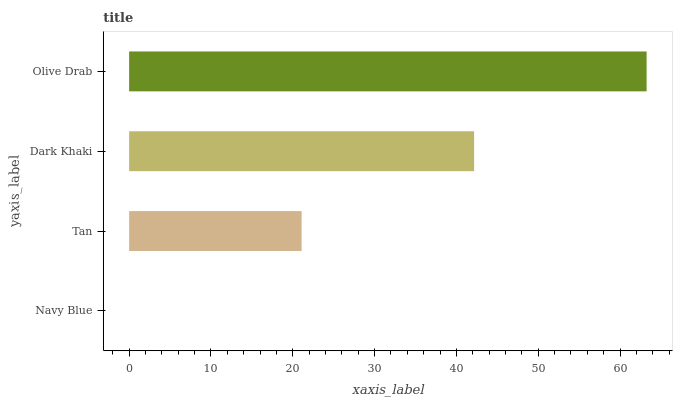Is Navy Blue the minimum?
Answer yes or no. Yes. Is Olive Drab the maximum?
Answer yes or no. Yes. Is Tan the minimum?
Answer yes or no. No. Is Tan the maximum?
Answer yes or no. No. Is Tan greater than Navy Blue?
Answer yes or no. Yes. Is Navy Blue less than Tan?
Answer yes or no. Yes. Is Navy Blue greater than Tan?
Answer yes or no. No. Is Tan less than Navy Blue?
Answer yes or no. No. Is Dark Khaki the high median?
Answer yes or no. Yes. Is Tan the low median?
Answer yes or no. Yes. Is Navy Blue the high median?
Answer yes or no. No. Is Olive Drab the low median?
Answer yes or no. No. 